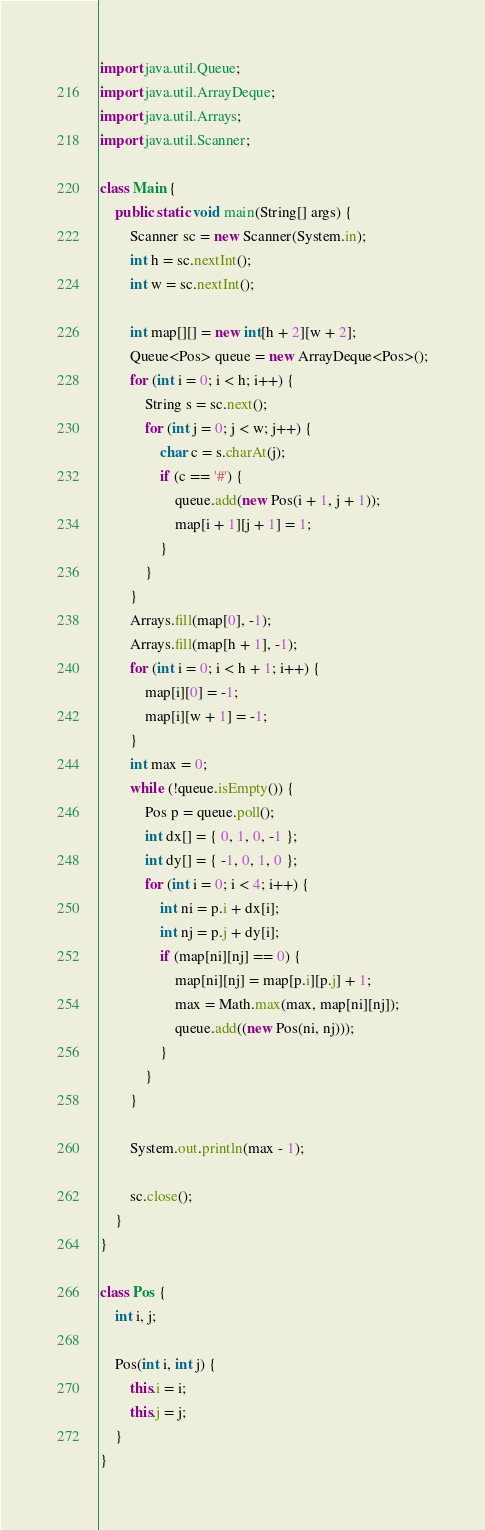Convert code to text. <code><loc_0><loc_0><loc_500><loc_500><_Java_>import java.util.Queue;
import java.util.ArrayDeque;
import java.util.Arrays;
import java.util.Scanner;

class Main {
    public static void main(String[] args) {
        Scanner sc = new Scanner(System.in);
        int h = sc.nextInt();
        int w = sc.nextInt();

        int map[][] = new int[h + 2][w + 2];
        Queue<Pos> queue = new ArrayDeque<Pos>();
        for (int i = 0; i < h; i++) {
            String s = sc.next();
            for (int j = 0; j < w; j++) {
                char c = s.charAt(j);
                if (c == '#') {
                    queue.add(new Pos(i + 1, j + 1));
                    map[i + 1][j + 1] = 1;
                }
            }
        }
        Arrays.fill(map[0], -1);
        Arrays.fill(map[h + 1], -1);
        for (int i = 0; i < h + 1; i++) {
            map[i][0] = -1;
            map[i][w + 1] = -1;
        }
        int max = 0;
        while (!queue.isEmpty()) {
            Pos p = queue.poll();
            int dx[] = { 0, 1, 0, -1 };
            int dy[] = { -1, 0, 1, 0 };
            for (int i = 0; i < 4; i++) {
                int ni = p.i + dx[i];
                int nj = p.j + dy[i];
                if (map[ni][nj] == 0) {
                    map[ni][nj] = map[p.i][p.j] + 1;
                    max = Math.max(max, map[ni][nj]);
                    queue.add((new Pos(ni, nj)));
                }
            }
        }

        System.out.println(max - 1);

        sc.close();
    }
}

class Pos {
    int i, j;

    Pos(int i, int j) {
        this.i = i;
        this.j = j;
    }
}
</code> 